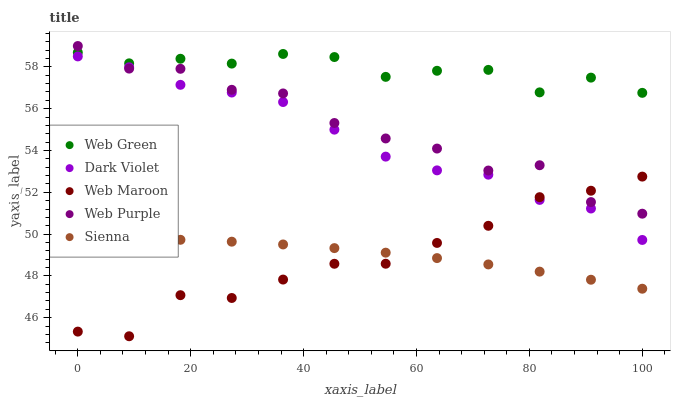Does Web Maroon have the minimum area under the curve?
Answer yes or no. Yes. Does Web Green have the maximum area under the curve?
Answer yes or no. Yes. Does Web Purple have the minimum area under the curve?
Answer yes or no. No. Does Web Purple have the maximum area under the curve?
Answer yes or no. No. Is Sienna the smoothest?
Answer yes or no. Yes. Is Web Purple the roughest?
Answer yes or no. Yes. Is Web Maroon the smoothest?
Answer yes or no. No. Is Web Maroon the roughest?
Answer yes or no. No. Does Web Maroon have the lowest value?
Answer yes or no. Yes. Does Web Purple have the lowest value?
Answer yes or no. No. Does Web Purple have the highest value?
Answer yes or no. Yes. Does Web Maroon have the highest value?
Answer yes or no. No. Is Sienna less than Web Green?
Answer yes or no. Yes. Is Web Green greater than Sienna?
Answer yes or no. Yes. Does Web Maroon intersect Dark Violet?
Answer yes or no. Yes. Is Web Maroon less than Dark Violet?
Answer yes or no. No. Is Web Maroon greater than Dark Violet?
Answer yes or no. No. Does Sienna intersect Web Green?
Answer yes or no. No. 